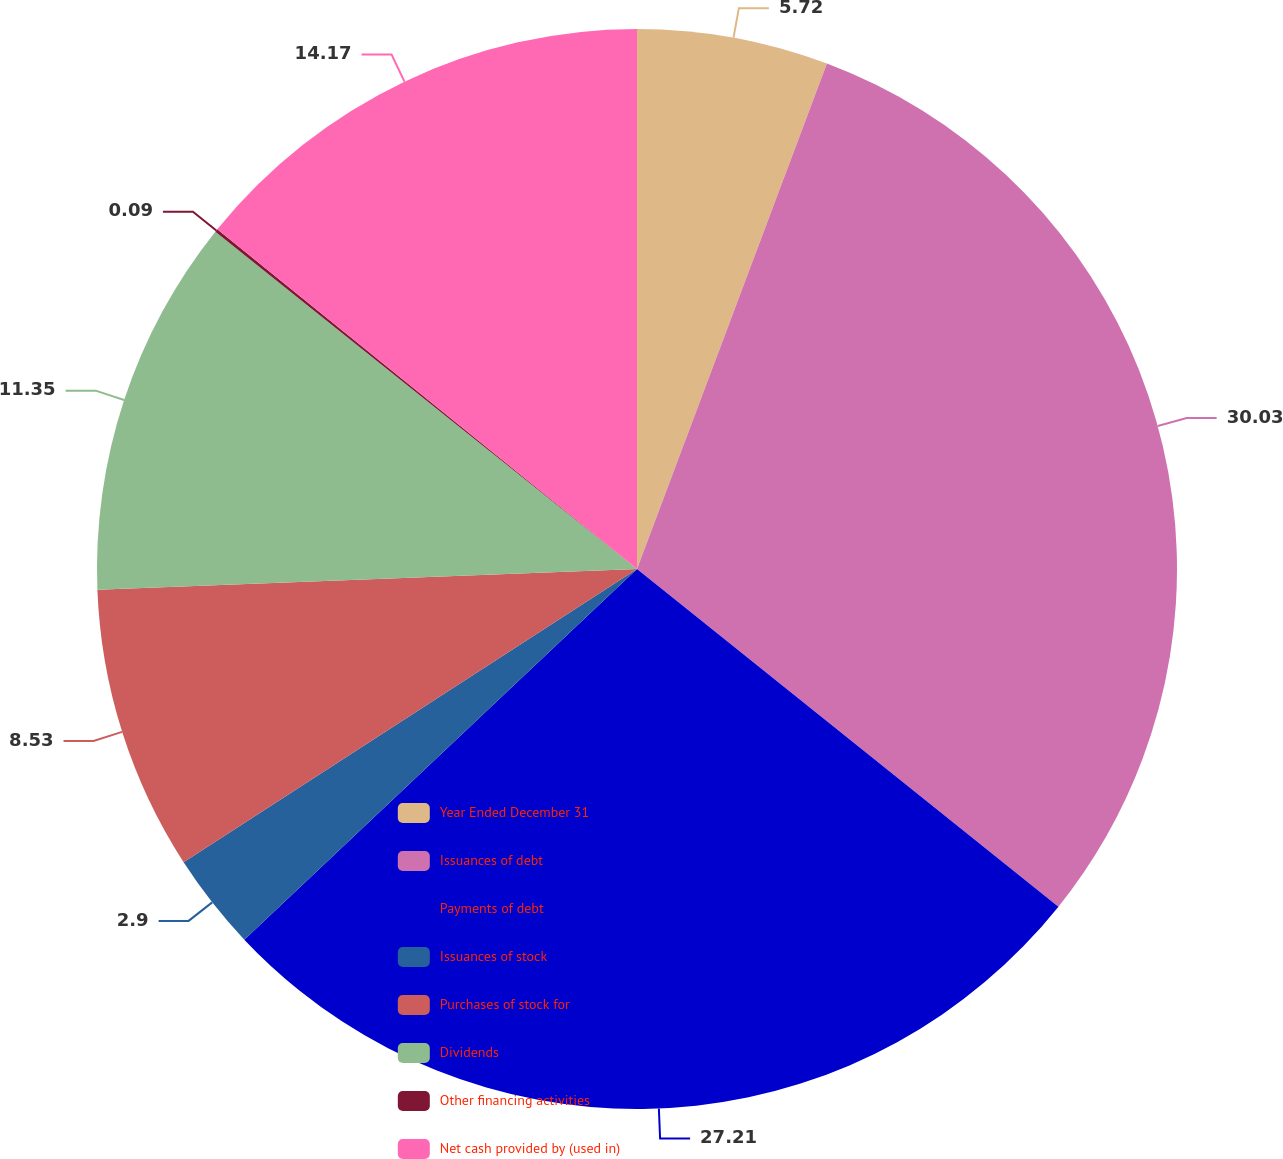Convert chart to OTSL. <chart><loc_0><loc_0><loc_500><loc_500><pie_chart><fcel>Year Ended December 31<fcel>Issuances of debt<fcel>Payments of debt<fcel>Issuances of stock<fcel>Purchases of stock for<fcel>Dividends<fcel>Other financing activities<fcel>Net cash provided by (used in)<nl><fcel>5.72%<fcel>30.03%<fcel>27.21%<fcel>2.9%<fcel>8.53%<fcel>11.35%<fcel>0.09%<fcel>14.17%<nl></chart> 